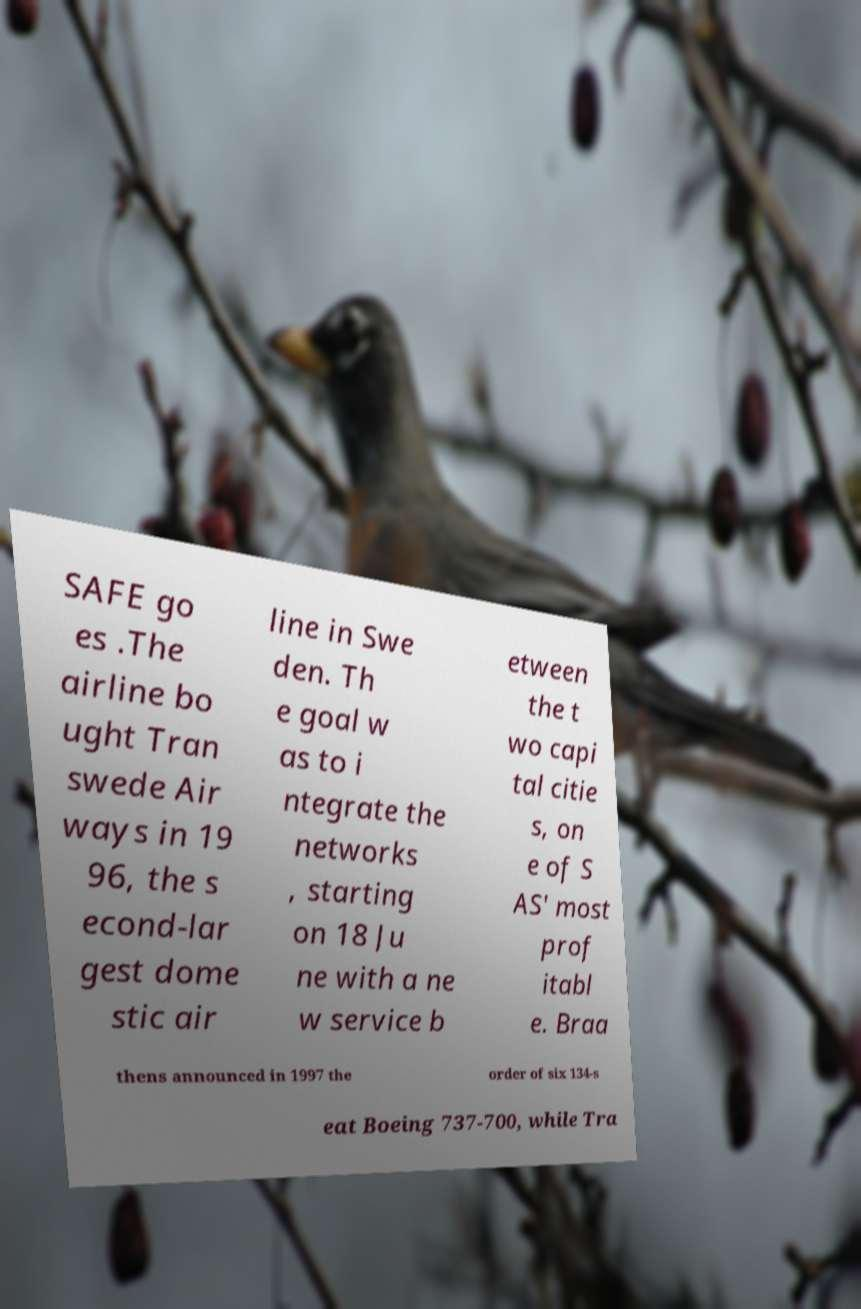Please read and relay the text visible in this image. What does it say? SAFE go es .The airline bo ught Tran swede Air ways in 19 96, the s econd-lar gest dome stic air line in Swe den. Th e goal w as to i ntegrate the networks , starting on 18 Ju ne with a ne w service b etween the t wo capi tal citie s, on e of S AS' most prof itabl e. Braa thens announced in 1997 the order of six 134-s eat Boeing 737-700, while Tra 